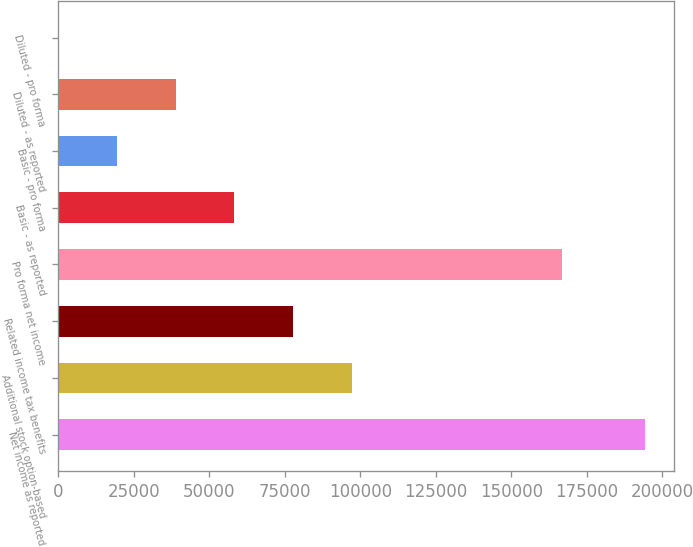<chart> <loc_0><loc_0><loc_500><loc_500><bar_chart><fcel>Net income as reported<fcel>Additional stock option-based<fcel>Related income tax benefits<fcel>Pro forma net income<fcel>Basic - as reported<fcel>Basic - pro forma<fcel>Diluted - as reported<fcel>Diluted - pro forma<nl><fcel>194254<fcel>97127.7<fcel>77702.4<fcel>166870<fcel>58277.1<fcel>19426.6<fcel>38851.8<fcel>1.31<nl></chart> 